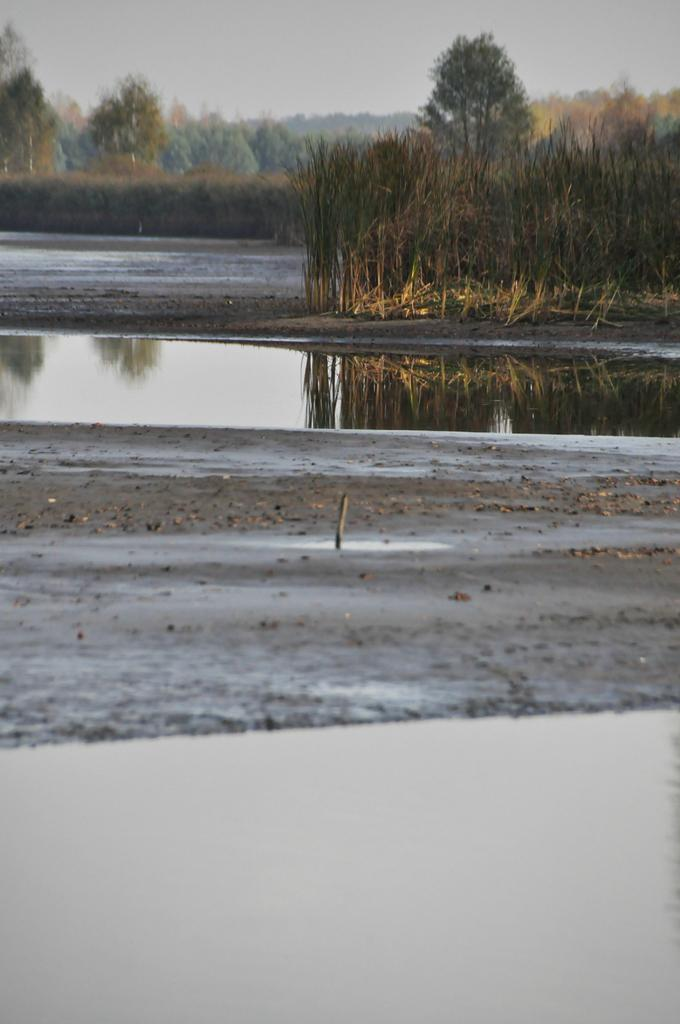What type of terrain is visible in the image? Ground and water are visible in the image. What type of vegetation is present in the image? Grass, plants, and trees are visible in the image. What is visible in the background of the image? The sky is visible in the background of the image. How do the tomatoes in the image contribute to the digestion process? There are no tomatoes present in the image, so their contribution to the digestion process cannot be determined. 